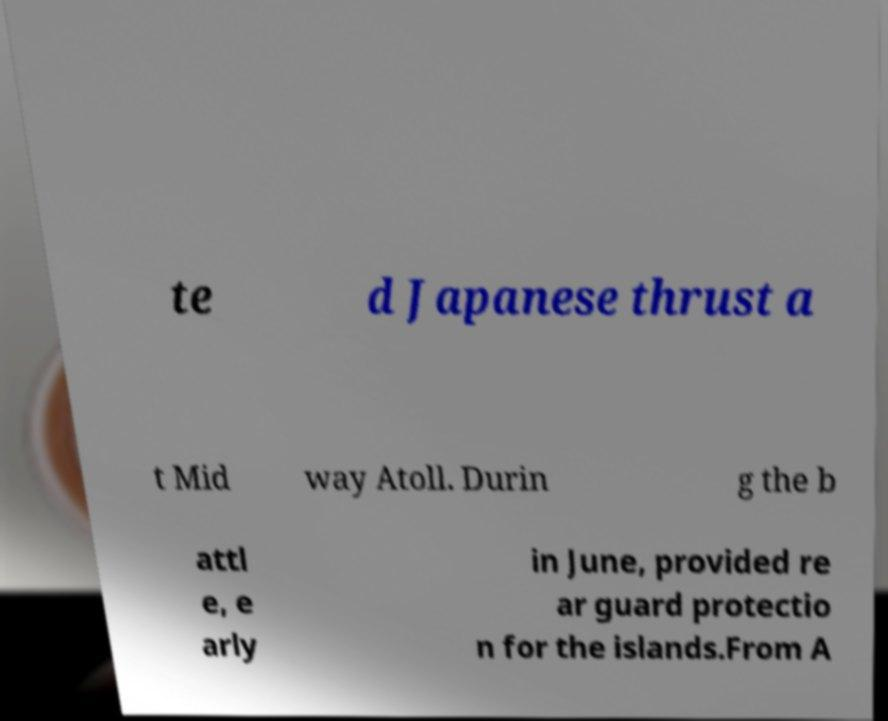Could you extract and type out the text from this image? te d Japanese thrust a t Mid way Atoll. Durin g the b attl e, e arly in June, provided re ar guard protectio n for the islands.From A 